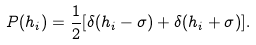<formula> <loc_0><loc_0><loc_500><loc_500>P ( h _ { i } ) = \frac { 1 } { 2 } [ \delta ( h _ { i } - \sigma ) + \delta ( h _ { i } + \sigma ) ] .</formula> 